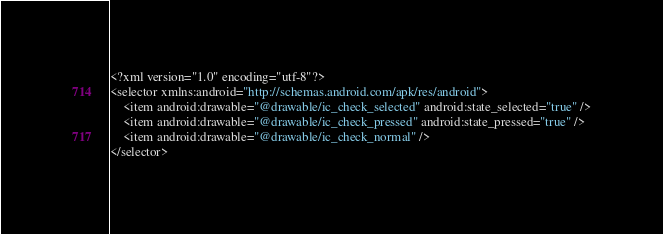Convert code to text. <code><loc_0><loc_0><loc_500><loc_500><_XML_><?xml version="1.0" encoding="utf-8"?>
<selector xmlns:android="http://schemas.android.com/apk/res/android">
    <item android:drawable="@drawable/ic_check_selected" android:state_selected="true" />
    <item android:drawable="@drawable/ic_check_pressed" android:state_pressed="true" />
    <item android:drawable="@drawable/ic_check_normal" />
</selector>
</code> 